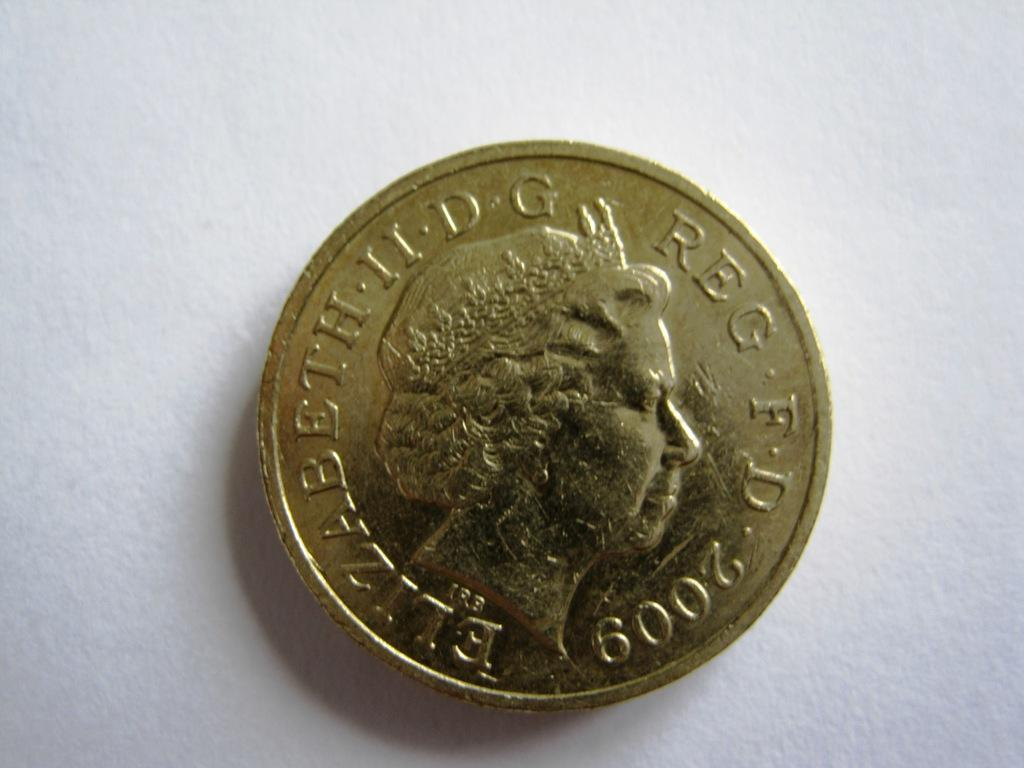<image>
Summarize the visual content of the image. A silver coin featuring Queen Elizabeth II from 2009 